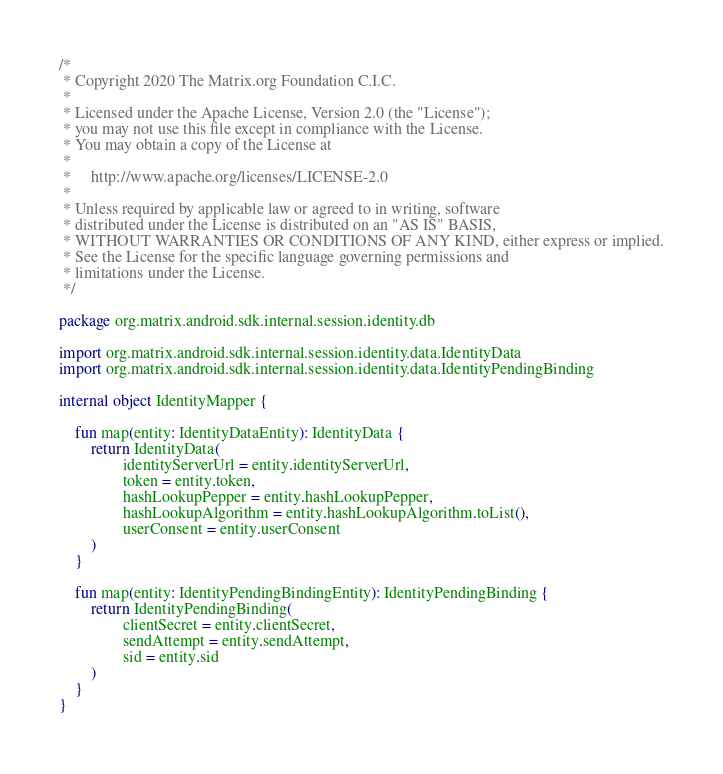<code> <loc_0><loc_0><loc_500><loc_500><_Kotlin_>/*
 * Copyright 2020 The Matrix.org Foundation C.I.C.
 *
 * Licensed under the Apache License, Version 2.0 (the "License");
 * you may not use this file except in compliance with the License.
 * You may obtain a copy of the License at
 *
 *     http://www.apache.org/licenses/LICENSE-2.0
 *
 * Unless required by applicable law or agreed to in writing, software
 * distributed under the License is distributed on an "AS IS" BASIS,
 * WITHOUT WARRANTIES OR CONDITIONS OF ANY KIND, either express or implied.
 * See the License for the specific language governing permissions and
 * limitations under the License.
 */

package org.matrix.android.sdk.internal.session.identity.db

import org.matrix.android.sdk.internal.session.identity.data.IdentityData
import org.matrix.android.sdk.internal.session.identity.data.IdentityPendingBinding

internal object IdentityMapper {

    fun map(entity: IdentityDataEntity): IdentityData {
        return IdentityData(
                identityServerUrl = entity.identityServerUrl,
                token = entity.token,
                hashLookupPepper = entity.hashLookupPepper,
                hashLookupAlgorithm = entity.hashLookupAlgorithm.toList(),
                userConsent = entity.userConsent
        )
    }

    fun map(entity: IdentityPendingBindingEntity): IdentityPendingBinding {
        return IdentityPendingBinding(
                clientSecret = entity.clientSecret,
                sendAttempt = entity.sendAttempt,
                sid = entity.sid
        )
    }
}
</code> 